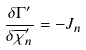Convert formula to latex. <formula><loc_0><loc_0><loc_500><loc_500>\frac { \delta \Gamma ^ { \prime } } { \delta \overline { \chi } _ { n } ^ { \prime } } = - J _ { n }</formula> 